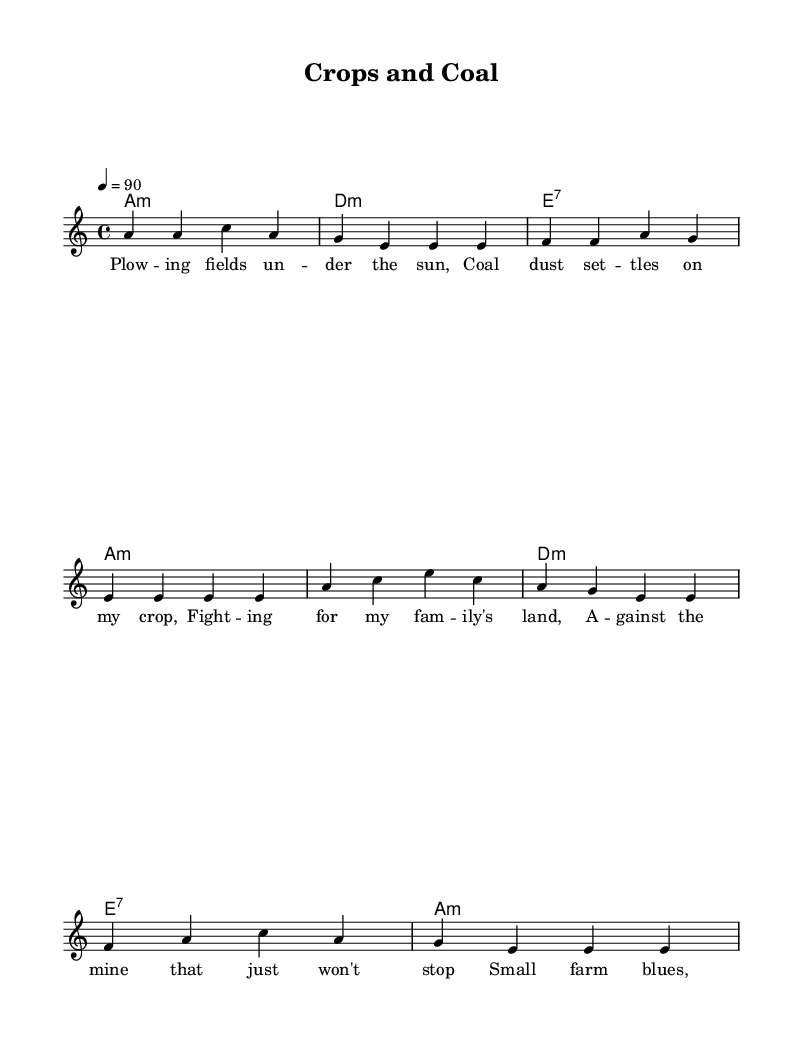What is the key signature of this music? The key signature is A minor, which typically has no sharps or flats. This can be determined by observing that the music is labeled with "a" in the global variable section, indicating it's in a minor key.
Answer: A minor What is the time signature of this music? The time signature is 4/4, as indicated by the notation in the global variable section. This means there are four beats in each measure, and the quarter note gets one beat.
Answer: 4/4 What is the tempo marking for this piece? The tempo is marked as 90 beats per minute, indicated by the "tempo 4 = 90" statement in the global variable. This tells the performer the speed at which to play the piece.
Answer: 90 How many lines are in the melody? There are four lines in the melody as it contains eight measures worth of notes separated into two groups of verse and chorus, which can be visually counted by looking at the melody notation.
Answer: Four What is the structure of the song? The structure consists of a verse followed by a chorus, which alternates as shown in the sheet music with distinct lyrics for the verse and chorus sections. This alternating structure is typical in electric blues songs.
Answer: Verse-Chorus What is the primary theme of the lyrics? The primary theme of the lyrics focuses on the struggles of small-scale farmers against the impacts of coal mining on their land, highlighting environmental concerns and resilience. This is evident in the lyrics' content that reflects personal and collective struggles.
Answer: Struggles against coal mining What type of chords is predominantly used in the harmonies? The predominant chords used in the harmonies are minor and dominant seventh chords, which are typical in Electric Blues, giving it a characteristic sound that reflects the emotional depth in the music. This is demonstrated by the presence of minor chords (like A minor, D minor) and the dominant seventh chord (E7).
Answer: Minor and dominant seventh 